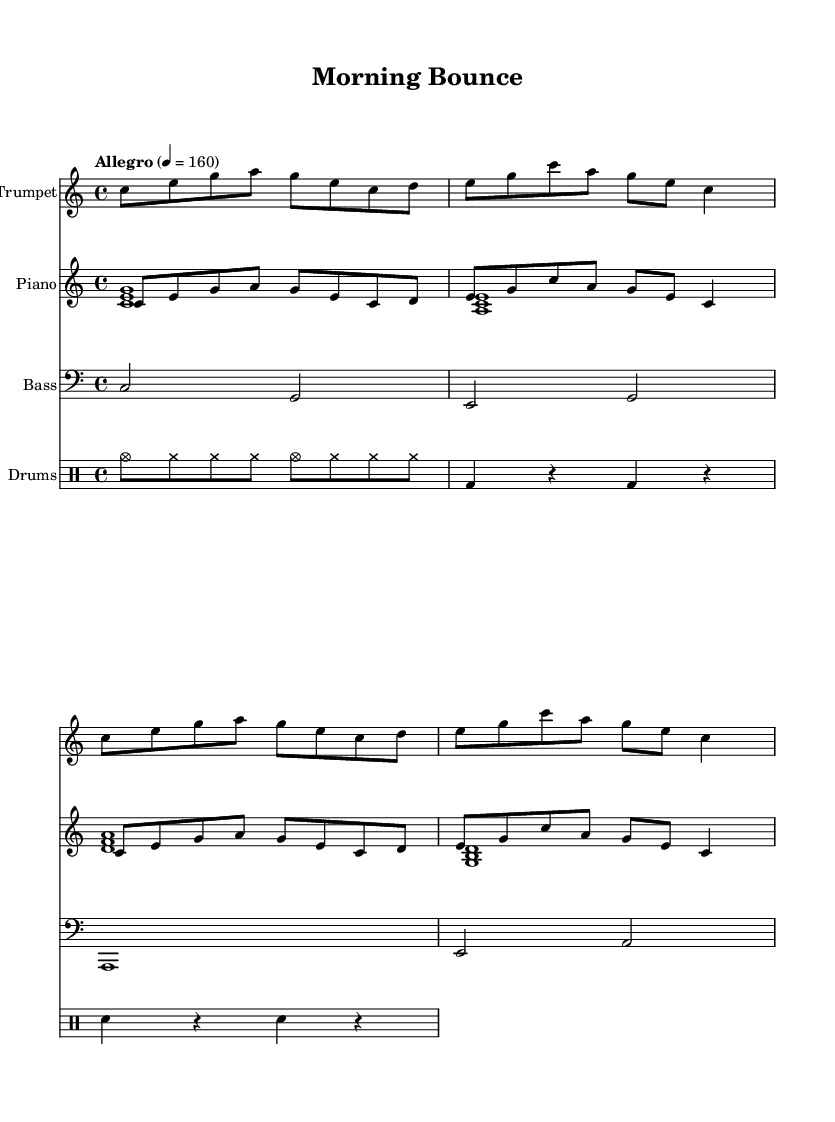What is the key signature of this music? The key signature is C major, which has no sharps or flats.
Answer: C major What is the time signature of this music? The time signature is indicated at the beginning of the sheet music, and it reads 4/4, meaning there are four beats per measure.
Answer: 4/4 What is the tempo marking for this piece? The tempo marking at the start states "Allegro" with a metronome marking of 4 = 160, indicating a lively pace.
Answer: Allegro 4 = 160 How many measures are in the trumpet part? To determine the number of measures, I can count the individual musical phrases in the trumpet part; there are a total of four measures.
Answer: 4 What instruments are featured in this piece? The piece features four instruments: Trumpet, Piano, Bass, and Drums, as all are explicitly listed in their corresponding parts.
Answer: Trumpet, Piano, Bass, Drums What type of jazz is this piece an example of? Given the upbeat nature and swing feel indicated by the tempo and rhythms in the parts, this piece exemplifies upbeat swing jazz.
Answer: Upbeat swing jazz 